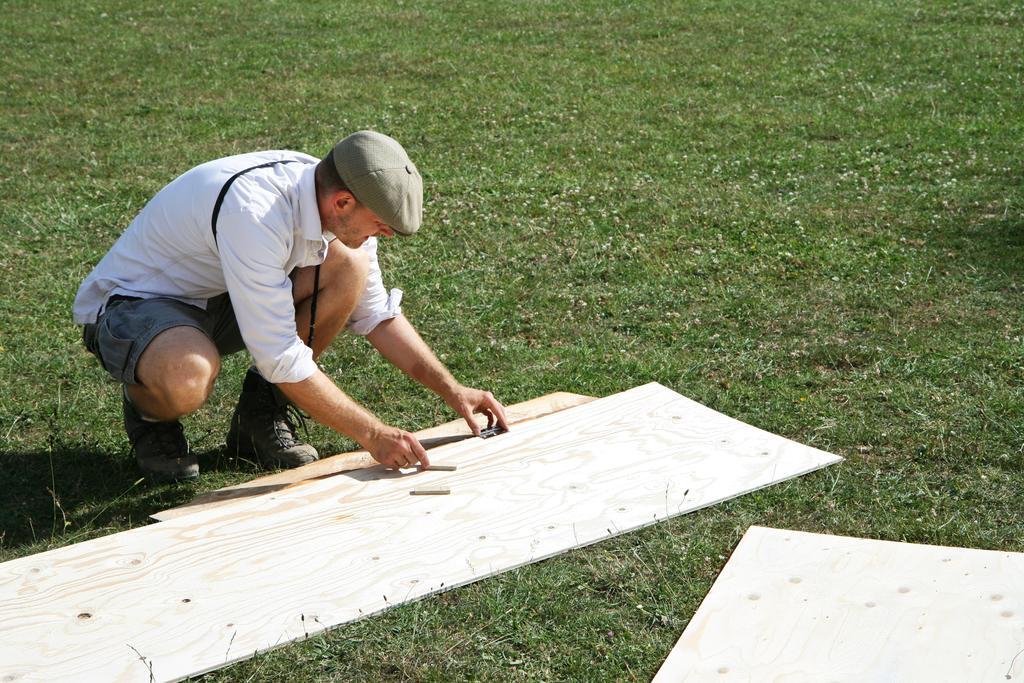Can you describe this image briefly? In the center of the image there is a person sitting at the cardboard. In the background we can see grass. 